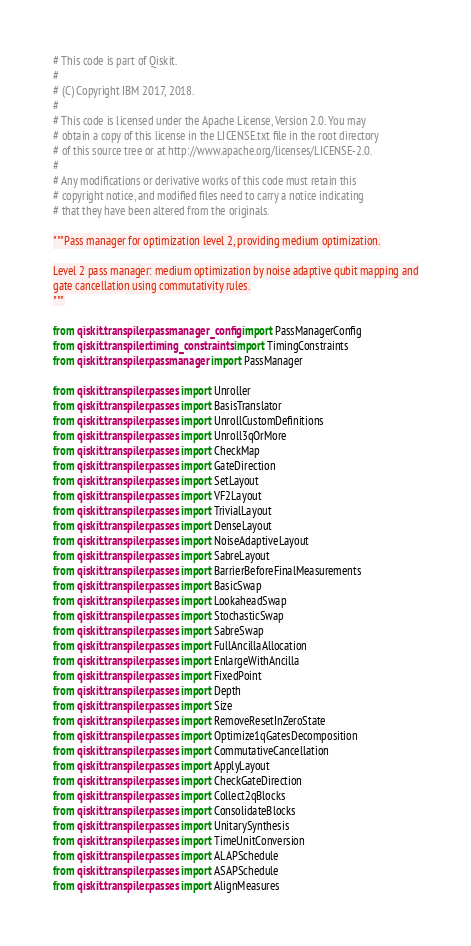<code> <loc_0><loc_0><loc_500><loc_500><_Python_># This code is part of Qiskit.
#
# (C) Copyright IBM 2017, 2018.
#
# This code is licensed under the Apache License, Version 2.0. You may
# obtain a copy of this license in the LICENSE.txt file in the root directory
# of this source tree or at http://www.apache.org/licenses/LICENSE-2.0.
#
# Any modifications or derivative works of this code must retain this
# copyright notice, and modified files need to carry a notice indicating
# that they have been altered from the originals.

"""Pass manager for optimization level 2, providing medium optimization.

Level 2 pass manager: medium optimization by noise adaptive qubit mapping and
gate cancellation using commutativity rules.
"""

from qiskit.transpiler.passmanager_config import PassManagerConfig
from qiskit.transpiler.timing_constraints import TimingConstraints
from qiskit.transpiler.passmanager import PassManager

from qiskit.transpiler.passes import Unroller
from qiskit.transpiler.passes import BasisTranslator
from qiskit.transpiler.passes import UnrollCustomDefinitions
from qiskit.transpiler.passes import Unroll3qOrMore
from qiskit.transpiler.passes import CheckMap
from qiskit.transpiler.passes import GateDirection
from qiskit.transpiler.passes import SetLayout
from qiskit.transpiler.passes import VF2Layout
from qiskit.transpiler.passes import TrivialLayout
from qiskit.transpiler.passes import DenseLayout
from qiskit.transpiler.passes import NoiseAdaptiveLayout
from qiskit.transpiler.passes import SabreLayout
from qiskit.transpiler.passes import BarrierBeforeFinalMeasurements
from qiskit.transpiler.passes import BasicSwap
from qiskit.transpiler.passes import LookaheadSwap
from qiskit.transpiler.passes import StochasticSwap
from qiskit.transpiler.passes import SabreSwap
from qiskit.transpiler.passes import FullAncillaAllocation
from qiskit.transpiler.passes import EnlargeWithAncilla
from qiskit.transpiler.passes import FixedPoint
from qiskit.transpiler.passes import Depth
from qiskit.transpiler.passes import Size
from qiskit.transpiler.passes import RemoveResetInZeroState
from qiskit.transpiler.passes import Optimize1qGatesDecomposition
from qiskit.transpiler.passes import CommutativeCancellation
from qiskit.transpiler.passes import ApplyLayout
from qiskit.transpiler.passes import CheckGateDirection
from qiskit.transpiler.passes import Collect2qBlocks
from qiskit.transpiler.passes import ConsolidateBlocks
from qiskit.transpiler.passes import UnitarySynthesis
from qiskit.transpiler.passes import TimeUnitConversion
from qiskit.transpiler.passes import ALAPSchedule
from qiskit.transpiler.passes import ASAPSchedule
from qiskit.transpiler.passes import AlignMeasures</code> 